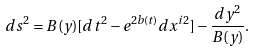Convert formula to latex. <formula><loc_0><loc_0><loc_500><loc_500>d s ^ { 2 } = B ( y ) [ d t ^ { 2 } - e ^ { 2 b ( t ) } d x ^ { i 2 } ] - \frac { d y ^ { 2 } } { B ( y ) } .</formula> 